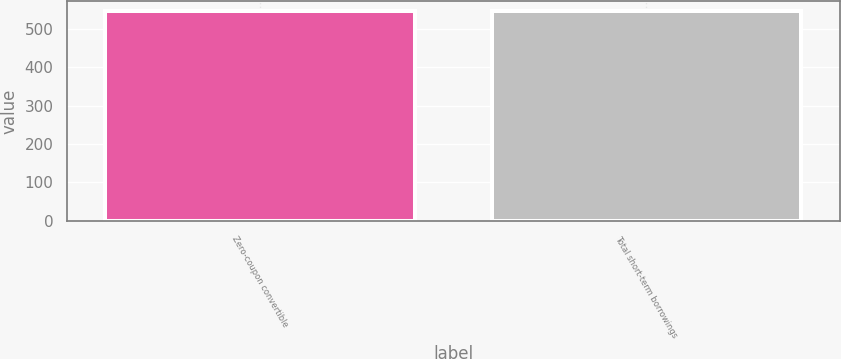Convert chart to OTSL. <chart><loc_0><loc_0><loc_500><loc_500><bar_chart><fcel>Zero-coupon convertible<fcel>Total short-term borrowings<nl><fcel>544.4<fcel>544.6<nl></chart> 